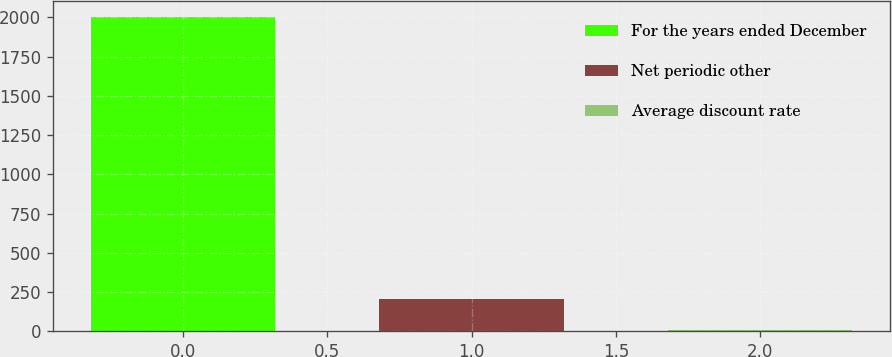Convert chart to OTSL. <chart><loc_0><loc_0><loc_500><loc_500><bar_chart><fcel>For the years ended December<fcel>Net periodic other<fcel>Average discount rate<nl><fcel>2005<fcel>205.63<fcel>5.7<nl></chart> 